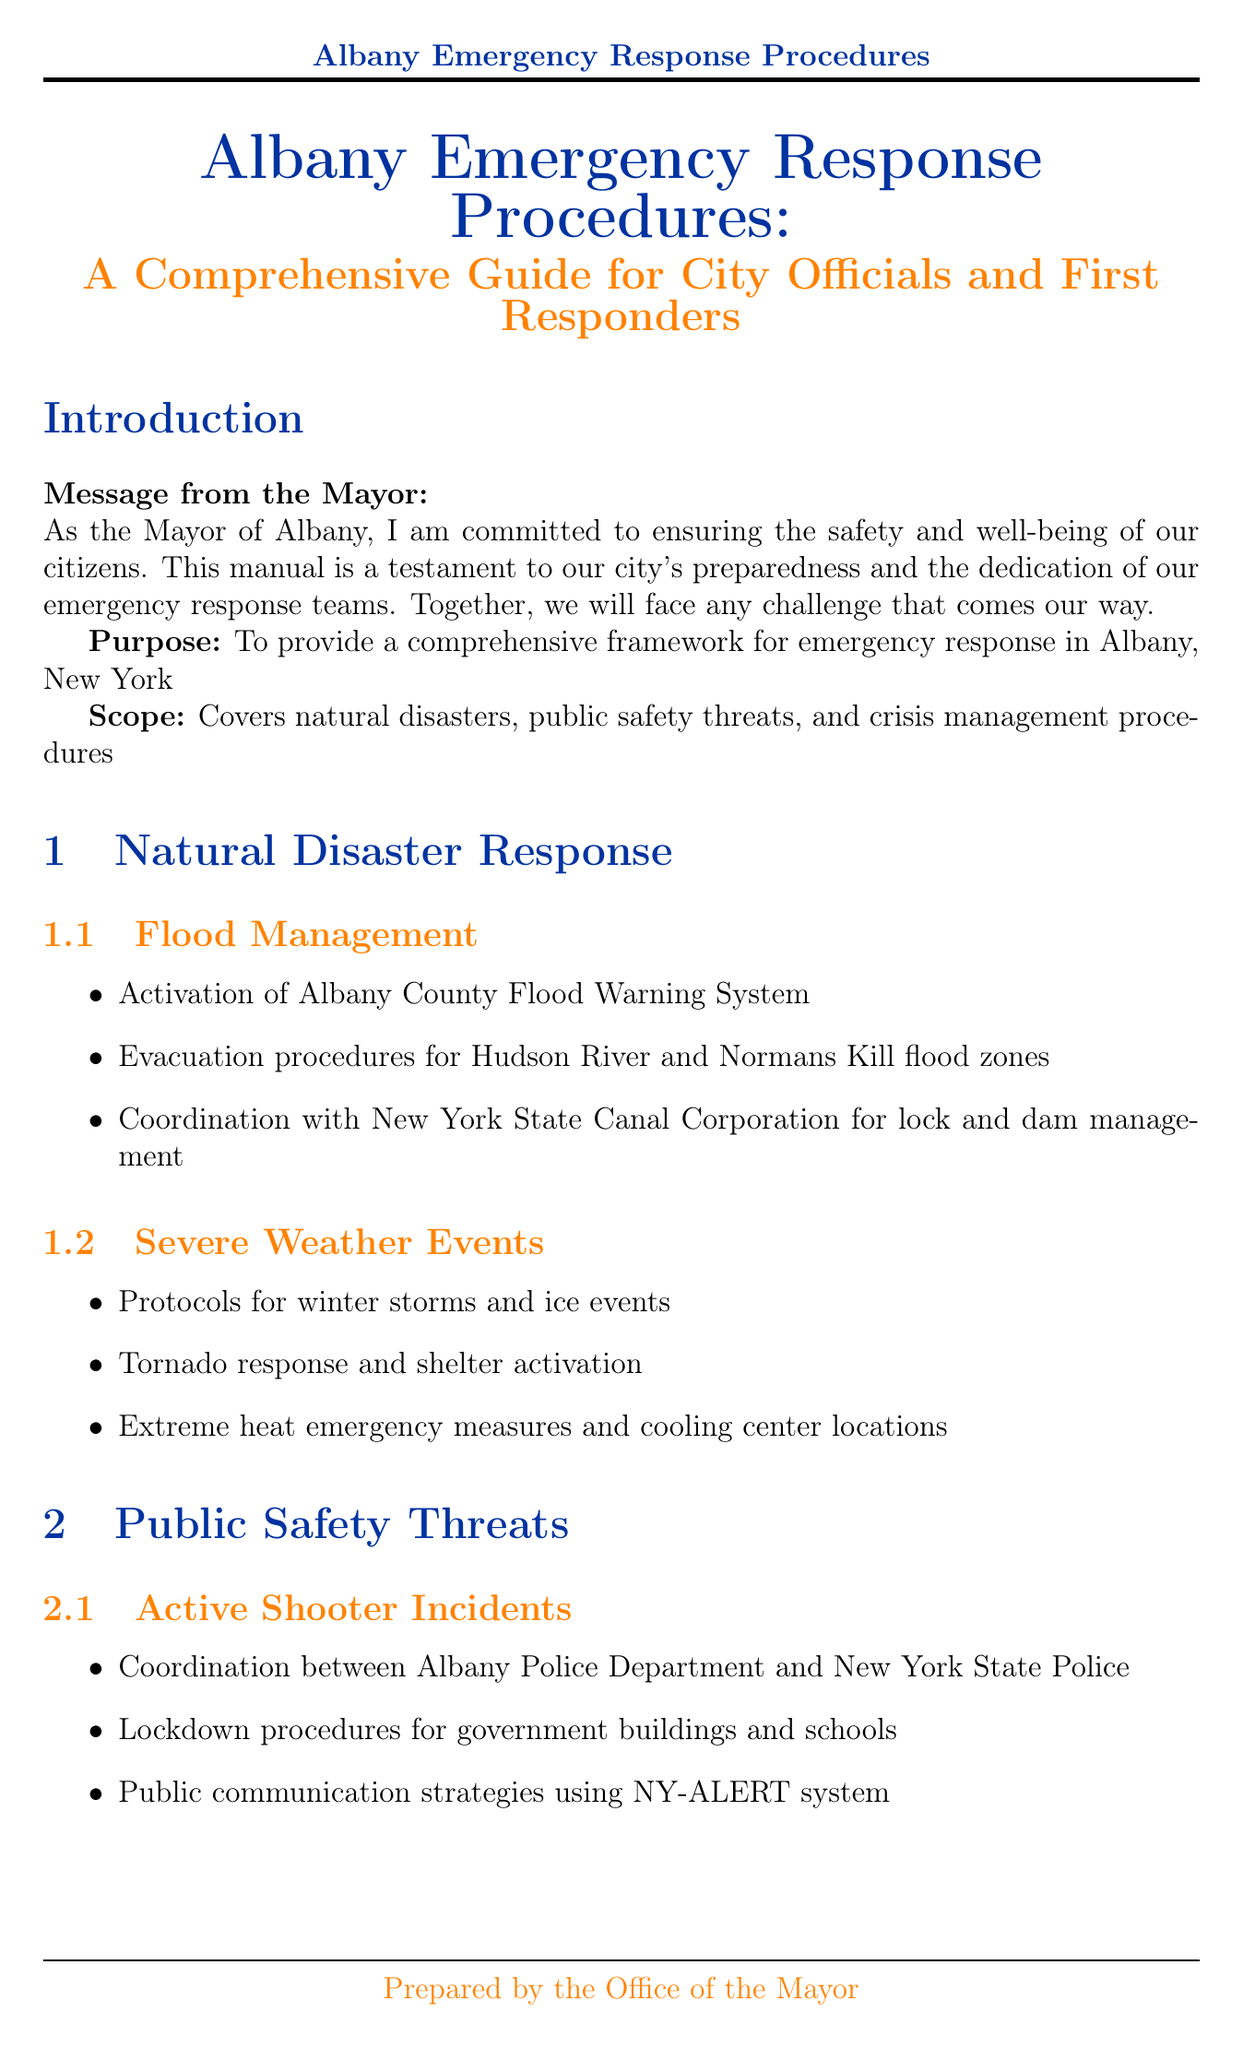What is the title of the manual? The title of the manual is found in the introduction section of the document.
Answer: Albany Emergency Response Procedures: A Comprehensive Guide for City Officials and First Responders How often is the manual scheduled for review? The review and update schedule is stated in the conclusion of the manual.
Answer: Annual review every September What is the emergency contact number for the Albany Police Department? Emergency contact information is listed in the appendices section of the document.
Answer: (518) 438-4000 What are the two main categories covered in the public safety threats chapter? The section titles in the chapter outline the key topics addressed.
Answer: Active Shooter Incidents and Hazardous Materials Incidents Which facility is used for mass vaccination plans? This information is specified in the public health emergencies section of the crisis management chapter.
Answer: Times Union Center What systems are activated for flood management? This is mentioned in the flood management section of the natural disaster response chapter.
Answer: Albany County Flood Warning System Who is responsible for coordinating during active shooter incidents? Coordination roles are described in the public safety threats section of the manual.
Answer: Albany Police Department and New York State Police What type of training is required for city employees? Training requirements are detailed in the conclusion of the manual.
Answer: Mandatory annual training for all city employees on basic emergency procedures 